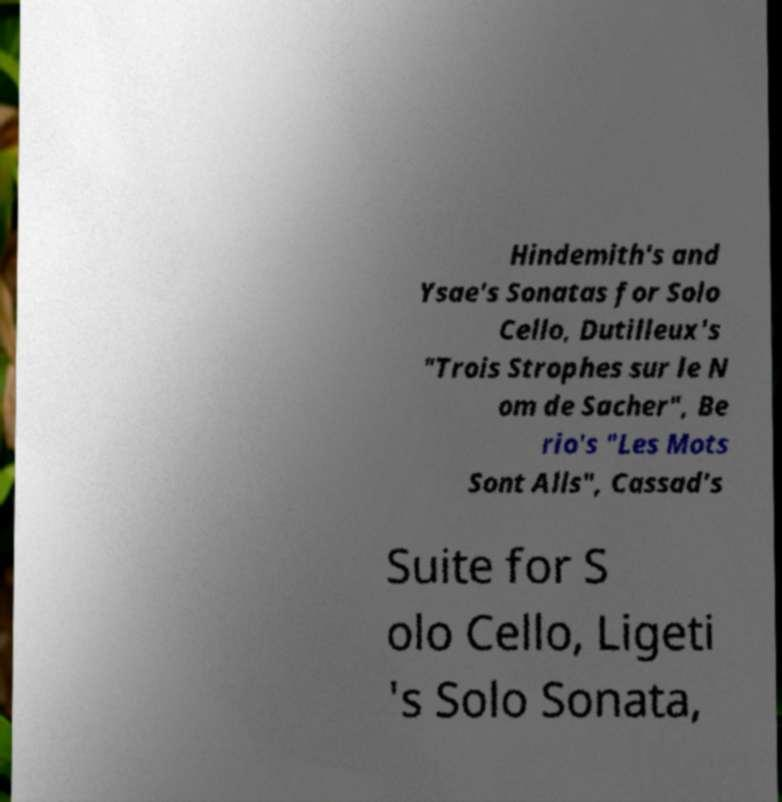For documentation purposes, I need the text within this image transcribed. Could you provide that? Hindemith's and Ysae's Sonatas for Solo Cello, Dutilleux's "Trois Strophes sur le N om de Sacher", Be rio's "Les Mots Sont Alls", Cassad's Suite for S olo Cello, Ligeti 's Solo Sonata, 